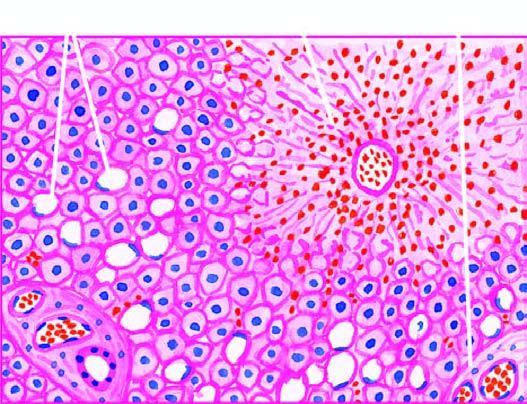what shows marked degeneration and necrosis of hepatocytes accompanied by haemorrhage while the peripheral zone shows mild fatty change of liver cells?
Answer the question using a single word or phrase. Centrilobular zone 